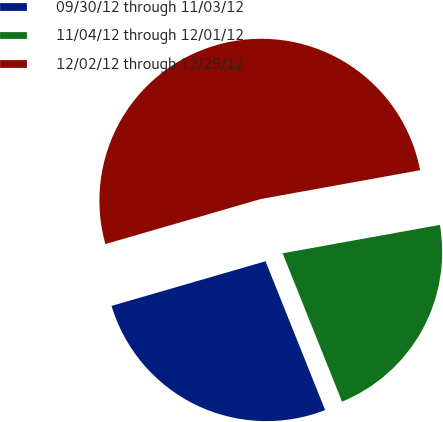<chart> <loc_0><loc_0><loc_500><loc_500><pie_chart><fcel>09/30/12 through 11/03/12<fcel>11/04/12 through 12/01/12<fcel>12/02/12 through 12/29/12<nl><fcel>26.57%<fcel>21.78%<fcel>51.64%<nl></chart> 